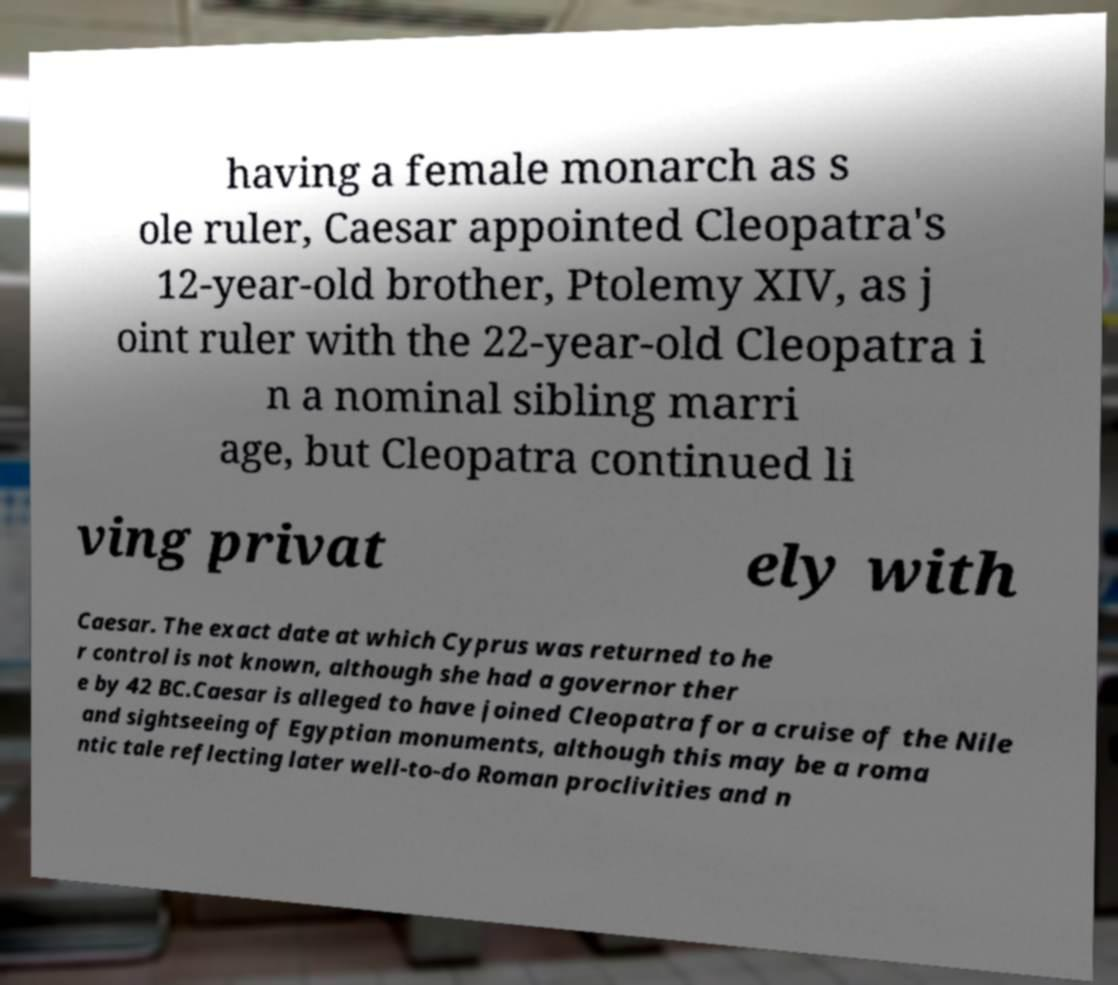What messages or text are displayed in this image? I need them in a readable, typed format. having a female monarch as s ole ruler, Caesar appointed Cleopatra's 12-year-old brother, Ptolemy XIV, as j oint ruler with the 22-year-old Cleopatra i n a nominal sibling marri age, but Cleopatra continued li ving privat ely with Caesar. The exact date at which Cyprus was returned to he r control is not known, although she had a governor ther e by 42 BC.Caesar is alleged to have joined Cleopatra for a cruise of the Nile and sightseeing of Egyptian monuments, although this may be a roma ntic tale reflecting later well-to-do Roman proclivities and n 